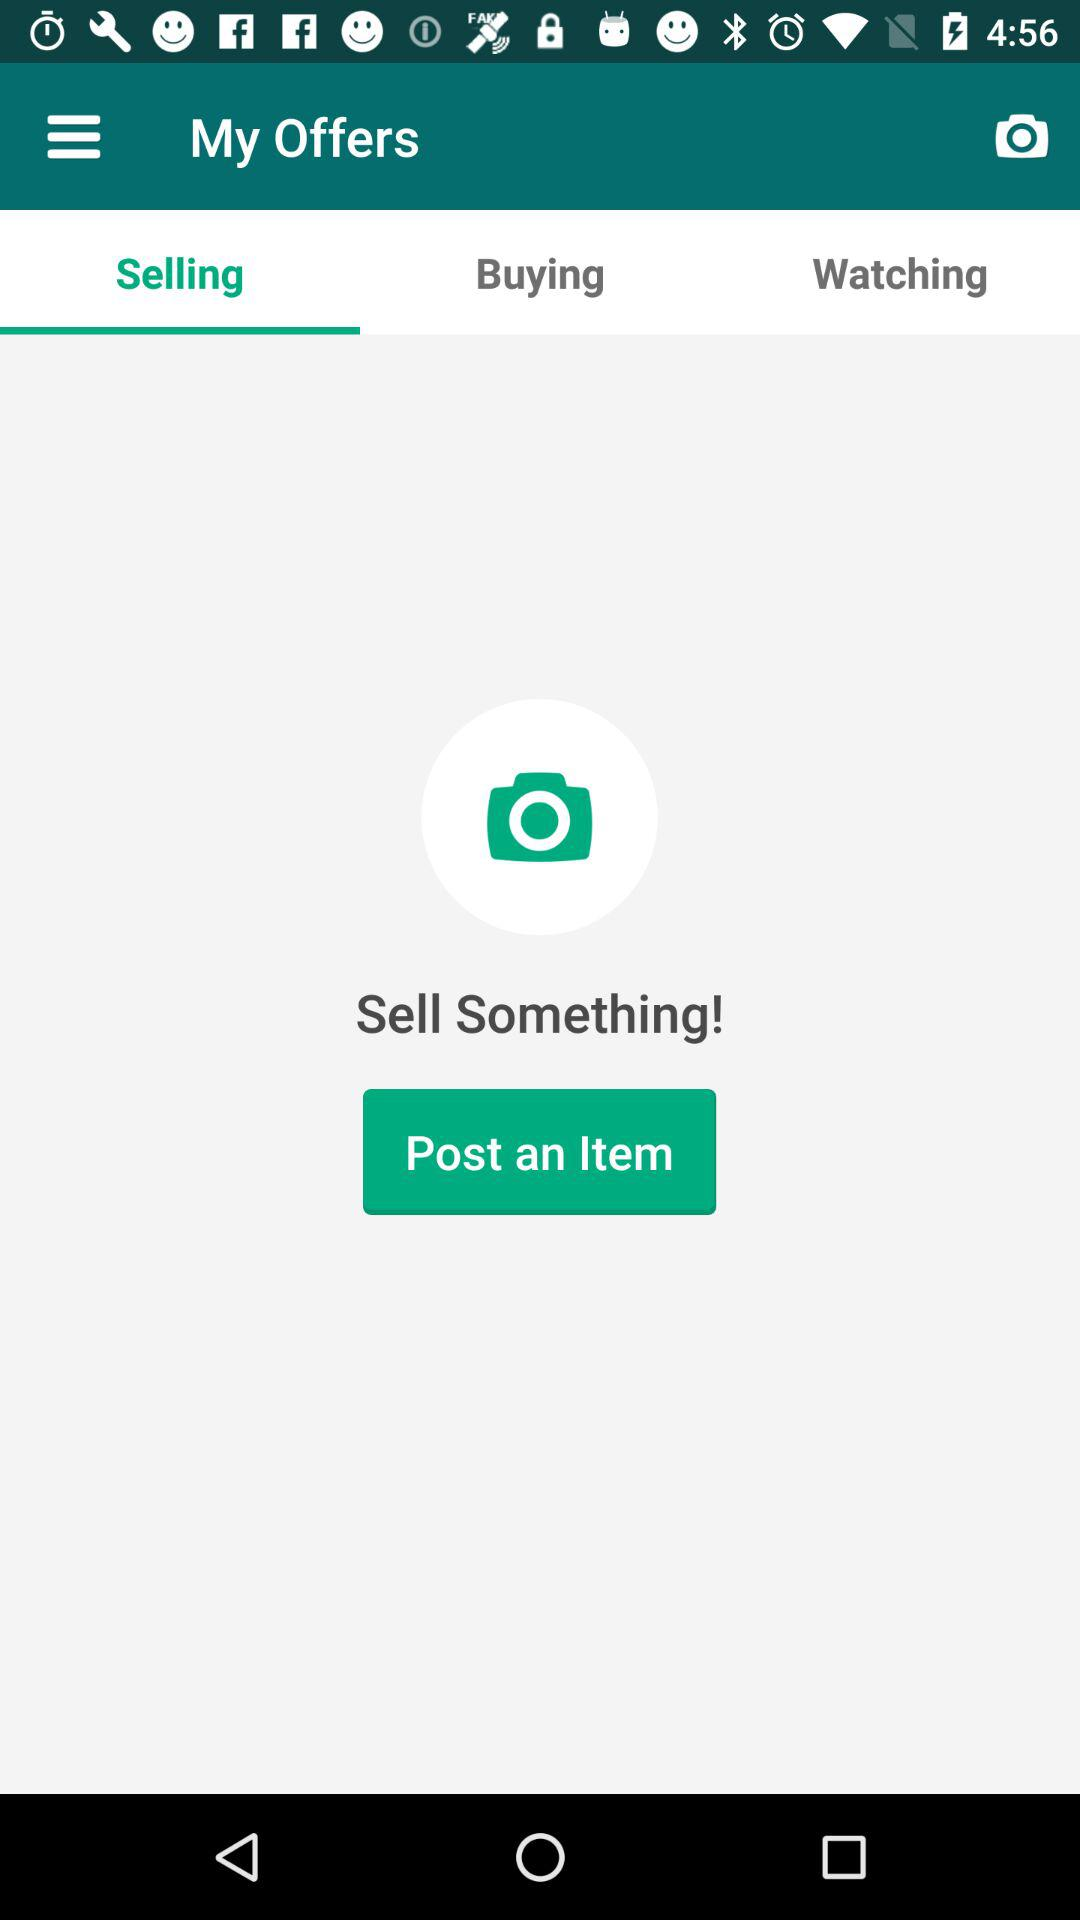Which tab has been selected? The selected tab is "Selling". 